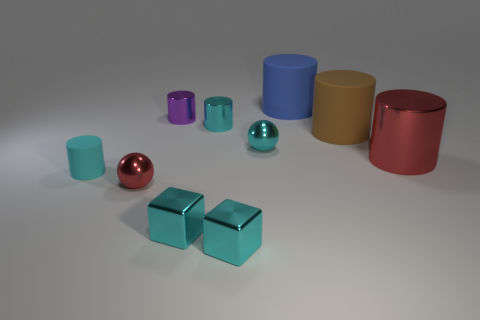Subtract all red metallic cylinders. How many cylinders are left? 5 Subtract all red cylinders. How many cylinders are left? 5 Subtract all blue cylinders. Subtract all blue spheres. How many cylinders are left? 5 Subtract all spheres. How many objects are left? 8 Add 7 cyan rubber cylinders. How many cyan rubber cylinders exist? 8 Subtract 0 gray cylinders. How many objects are left? 10 Subtract all large brown cubes. Subtract all small cyan matte things. How many objects are left? 9 Add 1 big blue things. How many big blue things are left? 2 